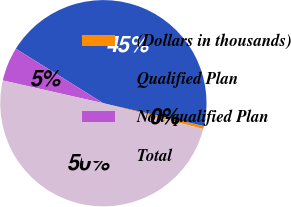<chart> <loc_0><loc_0><loc_500><loc_500><pie_chart><fcel>(Dollars in thousands)<fcel>Qualified Plan<fcel>Non-qualified Plan<fcel>Total<nl><fcel>0.48%<fcel>44.68%<fcel>5.32%<fcel>49.52%<nl></chart> 